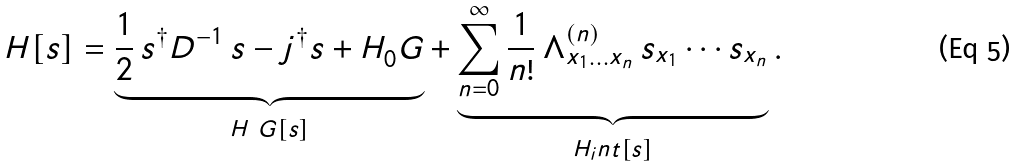Convert formula to latex. <formula><loc_0><loc_0><loc_500><loc_500>H [ s ] = \underbrace { \frac { 1 } { 2 } \, s ^ { \dagger } D ^ { - 1 } \, s - j ^ { \dagger } s + H _ { 0 } ^ { \ } G } _ { H _ { \ } G [ s ] } + \underbrace { \sum _ { n = 0 } ^ { \infty } \frac { 1 } { n ! } \, \Lambda ^ { ( n ) } _ { x _ { 1 } \dots x _ { n } } \, s _ { x _ { 1 } } \cdots s _ { x _ { n } } } _ { H _ { i } n t [ s ] } .</formula> 